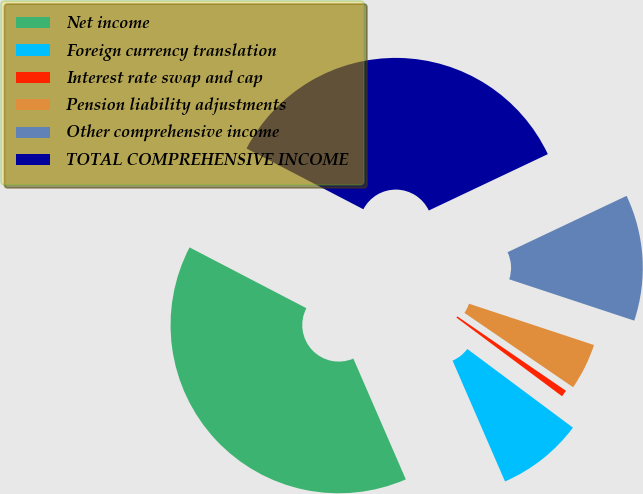<chart> <loc_0><loc_0><loc_500><loc_500><pie_chart><fcel>Net income<fcel>Foreign currency translation<fcel>Interest rate swap and cap<fcel>Pension liability adjustments<fcel>Other comprehensive income<fcel>TOTAL COMPREHENSIVE INCOME<nl><fcel>39.16%<fcel>8.29%<fcel>0.64%<fcel>4.47%<fcel>12.12%<fcel>35.33%<nl></chart> 